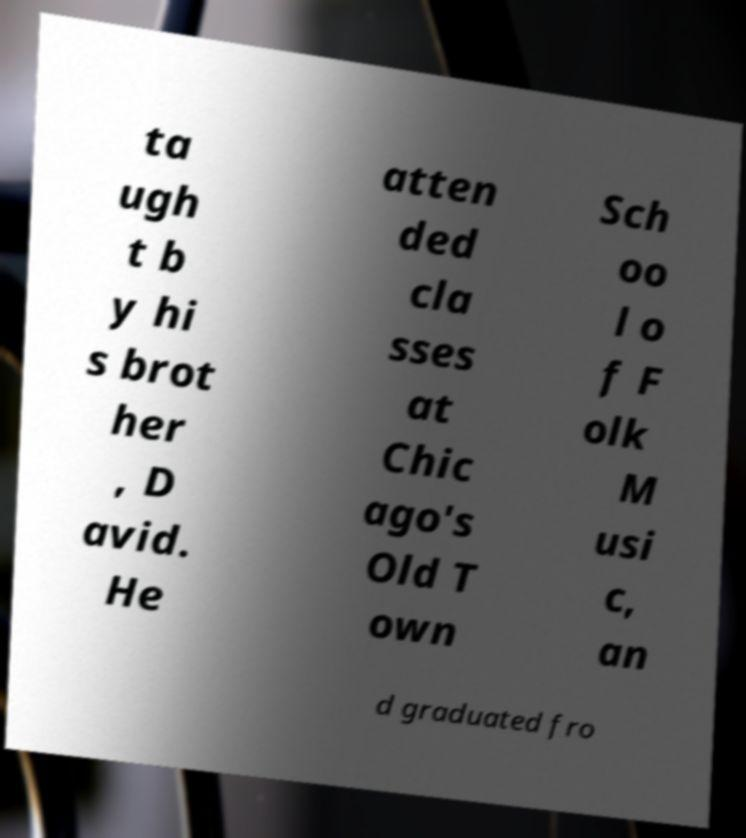Can you read and provide the text displayed in the image?This photo seems to have some interesting text. Can you extract and type it out for me? ta ugh t b y hi s brot her , D avid. He atten ded cla sses at Chic ago's Old T own Sch oo l o f F olk M usi c, an d graduated fro 